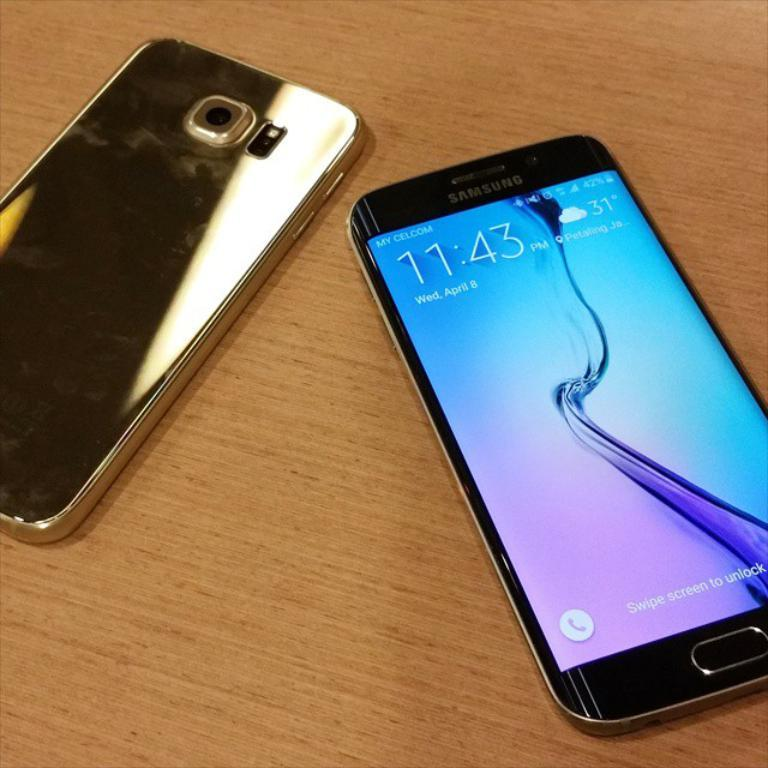Provide a one-sentence caption for the provided image. A cell phone displays the time on 11:43 and temperature of 31. 